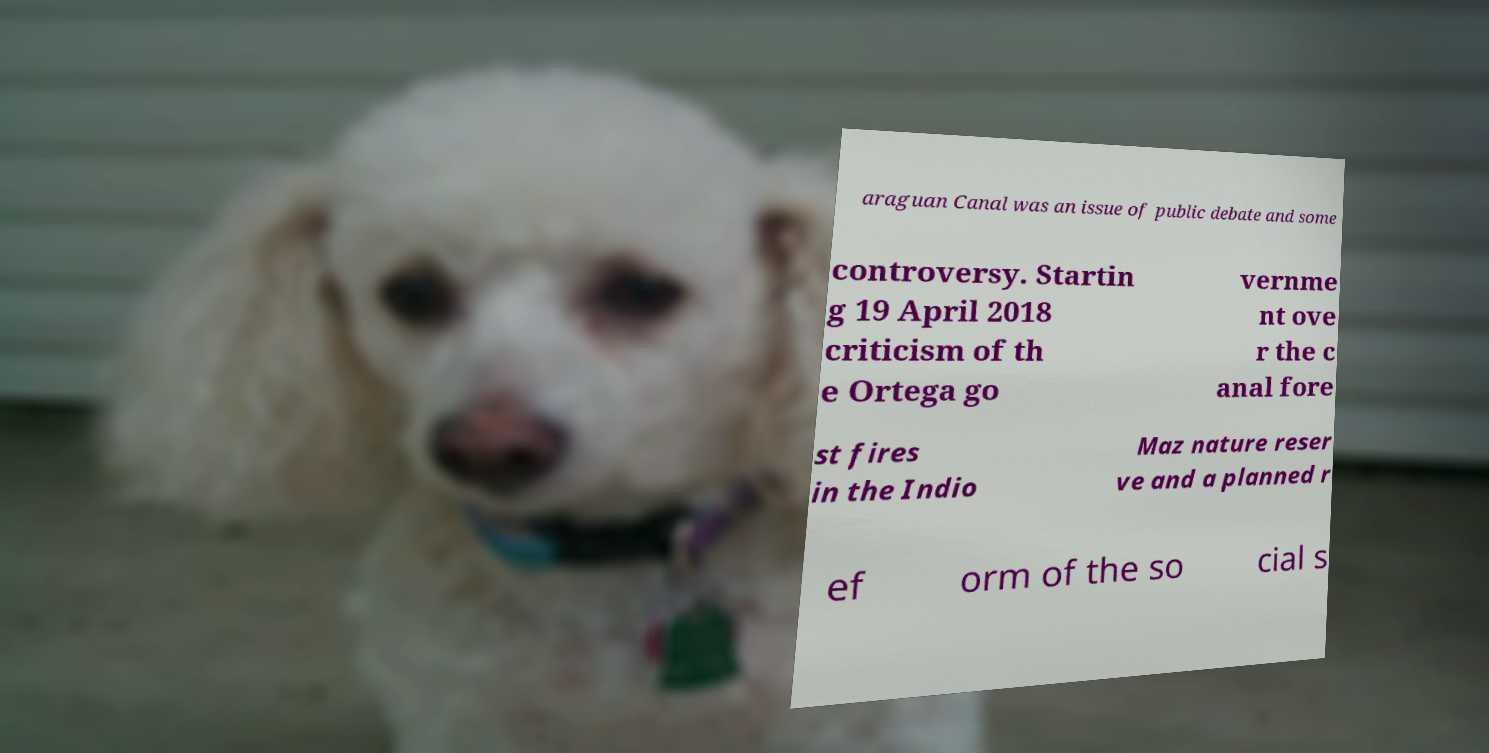What messages or text are displayed in this image? I need them in a readable, typed format. araguan Canal was an issue of public debate and some controversy. Startin g 19 April 2018 criticism of th e Ortega go vernme nt ove r the c anal fore st fires in the Indio Maz nature reser ve and a planned r ef orm of the so cial s 